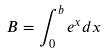<formula> <loc_0><loc_0><loc_500><loc_500>B = \int _ { 0 } ^ { b } e ^ { x } d x</formula> 